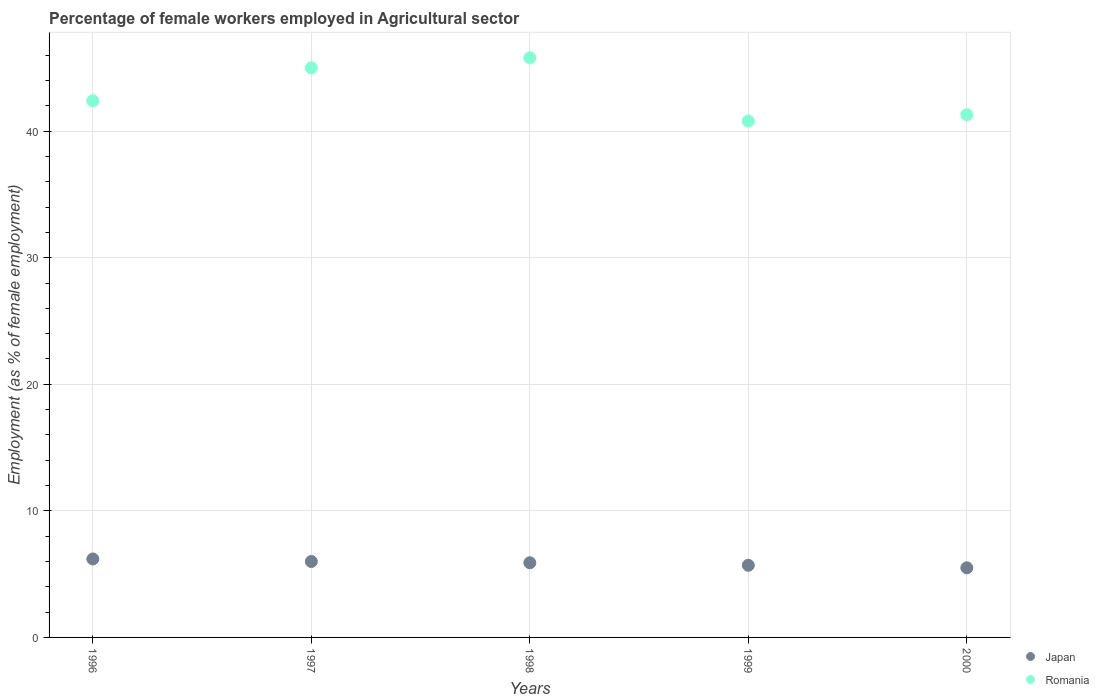Is the number of dotlines equal to the number of legend labels?
Offer a terse response. Yes. What is the percentage of females employed in Agricultural sector in Japan in 1999?
Offer a very short reply. 5.7. Across all years, what is the maximum percentage of females employed in Agricultural sector in Japan?
Keep it short and to the point. 6.2. Across all years, what is the minimum percentage of females employed in Agricultural sector in Romania?
Ensure brevity in your answer.  40.8. In which year was the percentage of females employed in Agricultural sector in Japan maximum?
Your answer should be very brief. 1996. What is the total percentage of females employed in Agricultural sector in Japan in the graph?
Offer a terse response. 29.3. What is the difference between the percentage of females employed in Agricultural sector in Japan in 2000 and the percentage of females employed in Agricultural sector in Romania in 1996?
Give a very brief answer. -36.9. What is the average percentage of females employed in Agricultural sector in Romania per year?
Keep it short and to the point. 43.06. In the year 1996, what is the difference between the percentage of females employed in Agricultural sector in Japan and percentage of females employed in Agricultural sector in Romania?
Ensure brevity in your answer.  -36.2. In how many years, is the percentage of females employed in Agricultural sector in Romania greater than 16 %?
Your answer should be very brief. 5. What is the ratio of the percentage of females employed in Agricultural sector in Romania in 1996 to that in 1997?
Give a very brief answer. 0.94. Is the percentage of females employed in Agricultural sector in Romania in 1996 less than that in 2000?
Your answer should be very brief. No. Is the difference between the percentage of females employed in Agricultural sector in Japan in 1996 and 1999 greater than the difference between the percentage of females employed in Agricultural sector in Romania in 1996 and 1999?
Your response must be concise. No. What is the difference between the highest and the second highest percentage of females employed in Agricultural sector in Romania?
Provide a succinct answer. 0.8. What is the difference between the highest and the lowest percentage of females employed in Agricultural sector in Romania?
Your response must be concise. 5. Is the percentage of females employed in Agricultural sector in Romania strictly greater than the percentage of females employed in Agricultural sector in Japan over the years?
Keep it short and to the point. Yes. Is the percentage of females employed in Agricultural sector in Japan strictly less than the percentage of females employed in Agricultural sector in Romania over the years?
Provide a succinct answer. Yes. How many dotlines are there?
Offer a very short reply. 2. How many years are there in the graph?
Provide a succinct answer. 5. Are the values on the major ticks of Y-axis written in scientific E-notation?
Ensure brevity in your answer.  No. Does the graph contain any zero values?
Offer a terse response. No. Where does the legend appear in the graph?
Keep it short and to the point. Bottom right. How many legend labels are there?
Offer a very short reply. 2. How are the legend labels stacked?
Provide a succinct answer. Vertical. What is the title of the graph?
Your answer should be compact. Percentage of female workers employed in Agricultural sector. Does "Least developed countries" appear as one of the legend labels in the graph?
Offer a terse response. No. What is the label or title of the Y-axis?
Make the answer very short. Employment (as % of female employment). What is the Employment (as % of female employment) in Japan in 1996?
Give a very brief answer. 6.2. What is the Employment (as % of female employment) of Romania in 1996?
Make the answer very short. 42.4. What is the Employment (as % of female employment) in Japan in 1998?
Keep it short and to the point. 5.9. What is the Employment (as % of female employment) in Romania in 1998?
Your answer should be very brief. 45.8. What is the Employment (as % of female employment) of Japan in 1999?
Offer a terse response. 5.7. What is the Employment (as % of female employment) in Romania in 1999?
Your answer should be compact. 40.8. What is the Employment (as % of female employment) in Romania in 2000?
Provide a succinct answer. 41.3. Across all years, what is the maximum Employment (as % of female employment) of Japan?
Ensure brevity in your answer.  6.2. Across all years, what is the maximum Employment (as % of female employment) of Romania?
Give a very brief answer. 45.8. Across all years, what is the minimum Employment (as % of female employment) of Japan?
Your response must be concise. 5.5. Across all years, what is the minimum Employment (as % of female employment) of Romania?
Provide a succinct answer. 40.8. What is the total Employment (as % of female employment) in Japan in the graph?
Your answer should be compact. 29.3. What is the total Employment (as % of female employment) of Romania in the graph?
Offer a terse response. 215.3. What is the difference between the Employment (as % of female employment) of Romania in 1996 and that in 1997?
Provide a short and direct response. -2.6. What is the difference between the Employment (as % of female employment) in Japan in 1996 and that in 1998?
Keep it short and to the point. 0.3. What is the difference between the Employment (as % of female employment) in Japan in 1996 and that in 1999?
Your response must be concise. 0.5. What is the difference between the Employment (as % of female employment) of Romania in 1996 and that in 1999?
Provide a succinct answer. 1.6. What is the difference between the Employment (as % of female employment) in Japan in 1997 and that in 1998?
Your answer should be very brief. 0.1. What is the difference between the Employment (as % of female employment) of Japan in 1998 and that in 1999?
Provide a succinct answer. 0.2. What is the difference between the Employment (as % of female employment) in Romania in 1998 and that in 1999?
Provide a succinct answer. 5. What is the difference between the Employment (as % of female employment) of Japan in 1999 and that in 2000?
Provide a short and direct response. 0.2. What is the difference between the Employment (as % of female employment) in Japan in 1996 and the Employment (as % of female employment) in Romania in 1997?
Give a very brief answer. -38.8. What is the difference between the Employment (as % of female employment) of Japan in 1996 and the Employment (as % of female employment) of Romania in 1998?
Offer a very short reply. -39.6. What is the difference between the Employment (as % of female employment) of Japan in 1996 and the Employment (as % of female employment) of Romania in 1999?
Provide a short and direct response. -34.6. What is the difference between the Employment (as % of female employment) in Japan in 1996 and the Employment (as % of female employment) in Romania in 2000?
Your answer should be compact. -35.1. What is the difference between the Employment (as % of female employment) of Japan in 1997 and the Employment (as % of female employment) of Romania in 1998?
Ensure brevity in your answer.  -39.8. What is the difference between the Employment (as % of female employment) of Japan in 1997 and the Employment (as % of female employment) of Romania in 1999?
Your answer should be compact. -34.8. What is the difference between the Employment (as % of female employment) in Japan in 1997 and the Employment (as % of female employment) in Romania in 2000?
Your answer should be very brief. -35.3. What is the difference between the Employment (as % of female employment) of Japan in 1998 and the Employment (as % of female employment) of Romania in 1999?
Provide a short and direct response. -34.9. What is the difference between the Employment (as % of female employment) of Japan in 1998 and the Employment (as % of female employment) of Romania in 2000?
Your answer should be very brief. -35.4. What is the difference between the Employment (as % of female employment) in Japan in 1999 and the Employment (as % of female employment) in Romania in 2000?
Give a very brief answer. -35.6. What is the average Employment (as % of female employment) of Japan per year?
Make the answer very short. 5.86. What is the average Employment (as % of female employment) of Romania per year?
Your answer should be compact. 43.06. In the year 1996, what is the difference between the Employment (as % of female employment) in Japan and Employment (as % of female employment) in Romania?
Offer a terse response. -36.2. In the year 1997, what is the difference between the Employment (as % of female employment) in Japan and Employment (as % of female employment) in Romania?
Ensure brevity in your answer.  -39. In the year 1998, what is the difference between the Employment (as % of female employment) in Japan and Employment (as % of female employment) in Romania?
Keep it short and to the point. -39.9. In the year 1999, what is the difference between the Employment (as % of female employment) of Japan and Employment (as % of female employment) of Romania?
Ensure brevity in your answer.  -35.1. In the year 2000, what is the difference between the Employment (as % of female employment) of Japan and Employment (as % of female employment) of Romania?
Your answer should be compact. -35.8. What is the ratio of the Employment (as % of female employment) of Japan in 1996 to that in 1997?
Your answer should be compact. 1.03. What is the ratio of the Employment (as % of female employment) of Romania in 1996 to that in 1997?
Keep it short and to the point. 0.94. What is the ratio of the Employment (as % of female employment) of Japan in 1996 to that in 1998?
Your response must be concise. 1.05. What is the ratio of the Employment (as % of female employment) of Romania in 1996 to that in 1998?
Your answer should be compact. 0.93. What is the ratio of the Employment (as % of female employment) in Japan in 1996 to that in 1999?
Provide a short and direct response. 1.09. What is the ratio of the Employment (as % of female employment) in Romania in 1996 to that in 1999?
Keep it short and to the point. 1.04. What is the ratio of the Employment (as % of female employment) in Japan in 1996 to that in 2000?
Your answer should be compact. 1.13. What is the ratio of the Employment (as % of female employment) in Romania in 1996 to that in 2000?
Provide a succinct answer. 1.03. What is the ratio of the Employment (as % of female employment) in Japan in 1997 to that in 1998?
Ensure brevity in your answer.  1.02. What is the ratio of the Employment (as % of female employment) in Romania in 1997 to that in 1998?
Provide a succinct answer. 0.98. What is the ratio of the Employment (as % of female employment) of Japan in 1997 to that in 1999?
Your answer should be very brief. 1.05. What is the ratio of the Employment (as % of female employment) in Romania in 1997 to that in 1999?
Provide a succinct answer. 1.1. What is the ratio of the Employment (as % of female employment) of Japan in 1997 to that in 2000?
Provide a short and direct response. 1.09. What is the ratio of the Employment (as % of female employment) of Romania in 1997 to that in 2000?
Ensure brevity in your answer.  1.09. What is the ratio of the Employment (as % of female employment) in Japan in 1998 to that in 1999?
Your response must be concise. 1.04. What is the ratio of the Employment (as % of female employment) of Romania in 1998 to that in 1999?
Give a very brief answer. 1.12. What is the ratio of the Employment (as % of female employment) in Japan in 1998 to that in 2000?
Make the answer very short. 1.07. What is the ratio of the Employment (as % of female employment) of Romania in 1998 to that in 2000?
Provide a short and direct response. 1.11. What is the ratio of the Employment (as % of female employment) in Japan in 1999 to that in 2000?
Provide a short and direct response. 1.04. What is the ratio of the Employment (as % of female employment) of Romania in 1999 to that in 2000?
Keep it short and to the point. 0.99. What is the difference between the highest and the second highest Employment (as % of female employment) of Japan?
Your response must be concise. 0.2. What is the difference between the highest and the lowest Employment (as % of female employment) in Japan?
Ensure brevity in your answer.  0.7. 